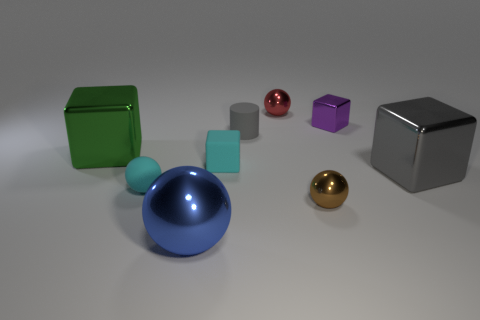Subtract all green metallic blocks. How many blocks are left? 3 Subtract all blue balls. How many balls are left? 3 Subtract all cubes. How many objects are left? 5 Add 1 objects. How many objects exist? 10 Subtract all yellow cylinders. How many cyan balls are left? 1 Subtract all tiny gray things. Subtract all large shiny cubes. How many objects are left? 6 Add 1 small cyan matte things. How many small cyan matte things are left? 3 Add 6 cylinders. How many cylinders exist? 7 Subtract 0 cyan cylinders. How many objects are left? 9 Subtract 1 cylinders. How many cylinders are left? 0 